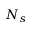<formula> <loc_0><loc_0><loc_500><loc_500>N _ { s }</formula> 